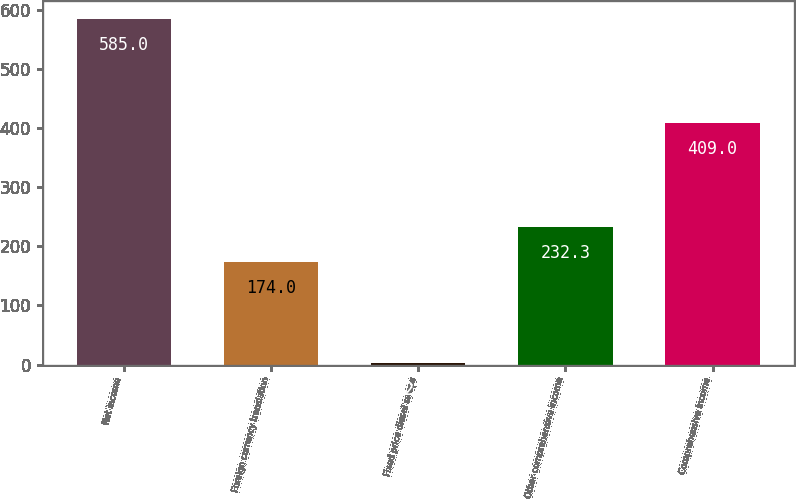Convert chart. <chart><loc_0><loc_0><loc_500><loc_500><bar_chart><fcel>Net income<fcel>Foreign currency translation<fcel>Fixed price diesel swaps<fcel>Other comprehensive income<fcel>Comprehensive income<nl><fcel>585<fcel>174<fcel>2<fcel>232.3<fcel>409<nl></chart> 